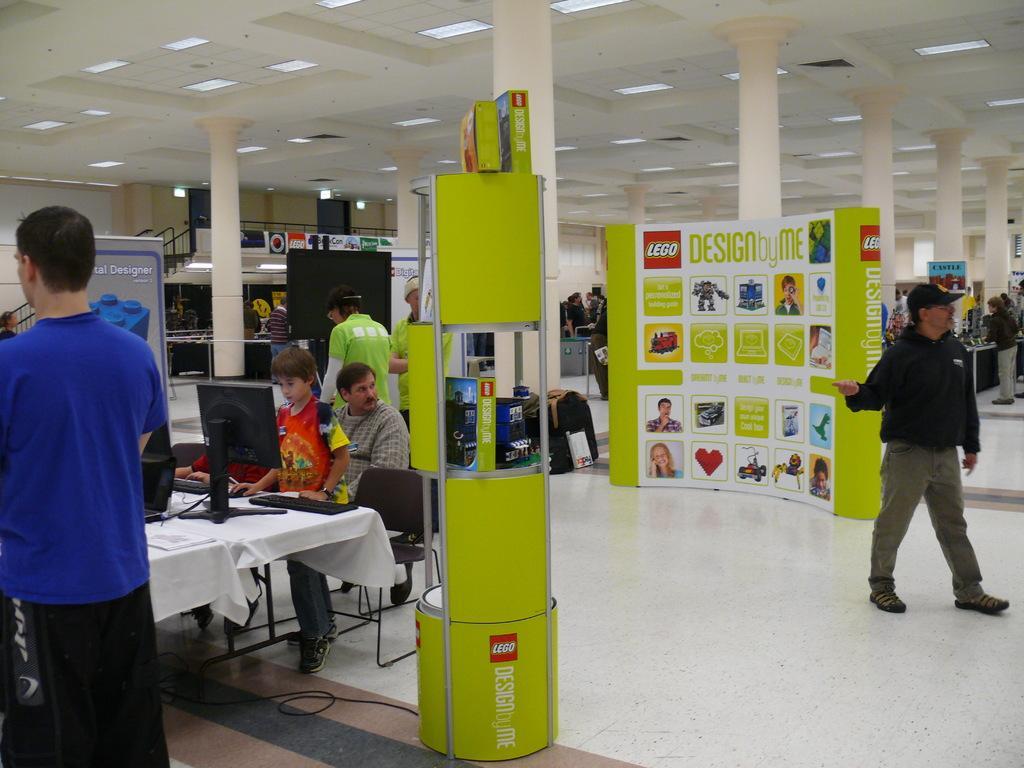Please provide a concise description of this image. There are some people standing, walking here. One man is sitting in the chair in front of a table on which a computer was placed. There is a boy in front of a computer. In the background there is a poster, pillar, railing and a wall here. 